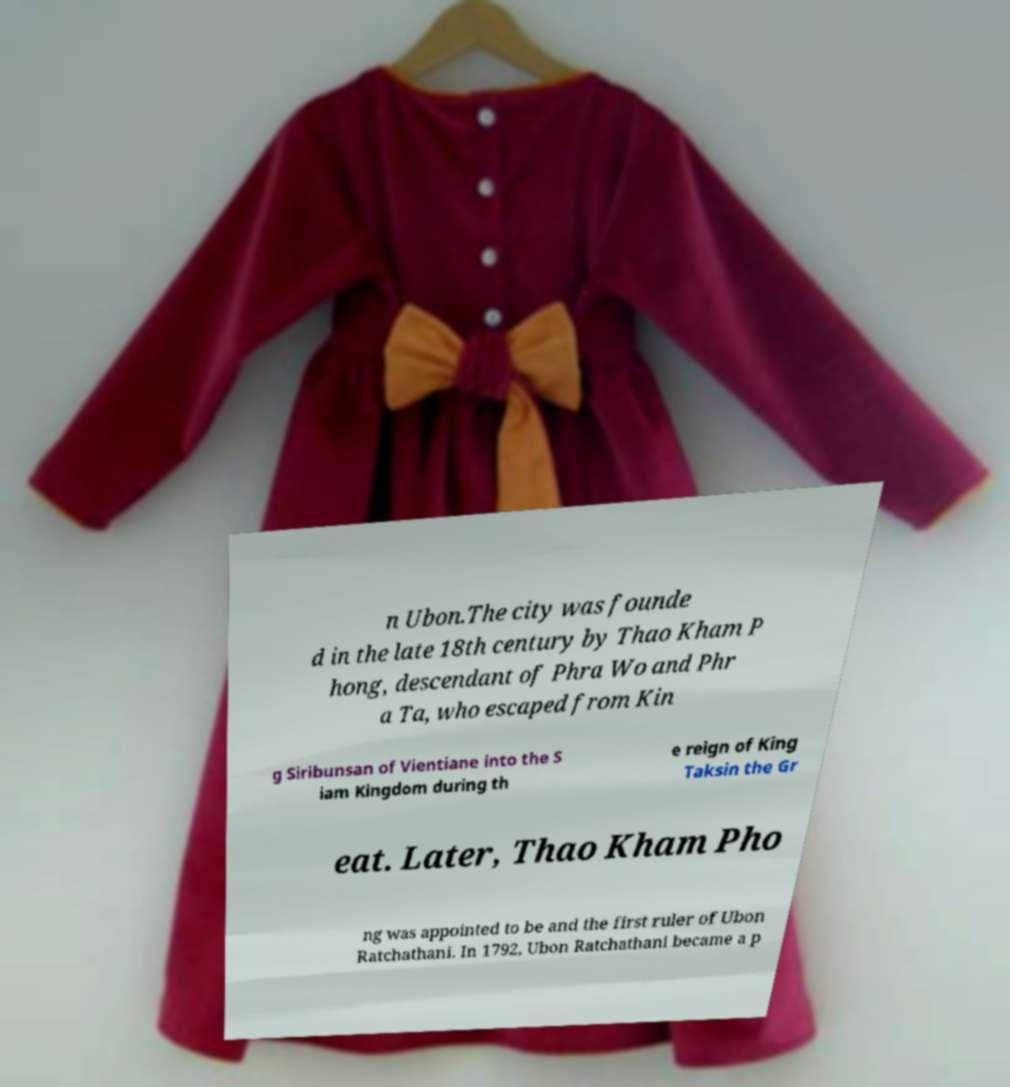I need the written content from this picture converted into text. Can you do that? n Ubon.The city was founde d in the late 18th century by Thao Kham P hong, descendant of Phra Wo and Phr a Ta, who escaped from Kin g Siribunsan of Vientiane into the S iam Kingdom during th e reign of King Taksin the Gr eat. Later, Thao Kham Pho ng was appointed to be and the first ruler of Ubon Ratchathani. In 1792, Ubon Ratchathani became a p 